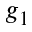<formula> <loc_0><loc_0><loc_500><loc_500>g _ { 1 }</formula> 